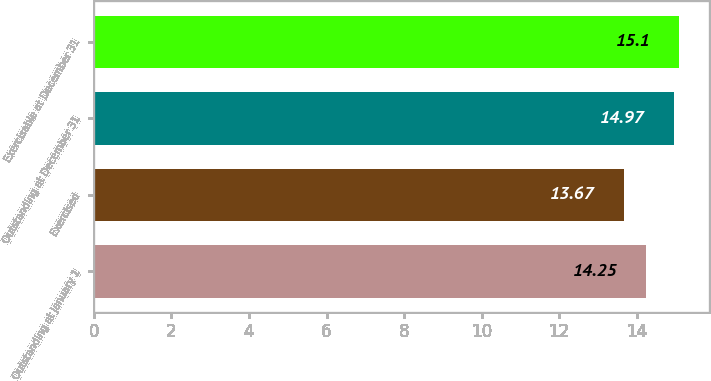<chart> <loc_0><loc_0><loc_500><loc_500><bar_chart><fcel>Outstanding at January 1<fcel>Exercised<fcel>Outstanding at December 31<fcel>Exercisable at December 31<nl><fcel>14.25<fcel>13.67<fcel>14.97<fcel>15.1<nl></chart> 